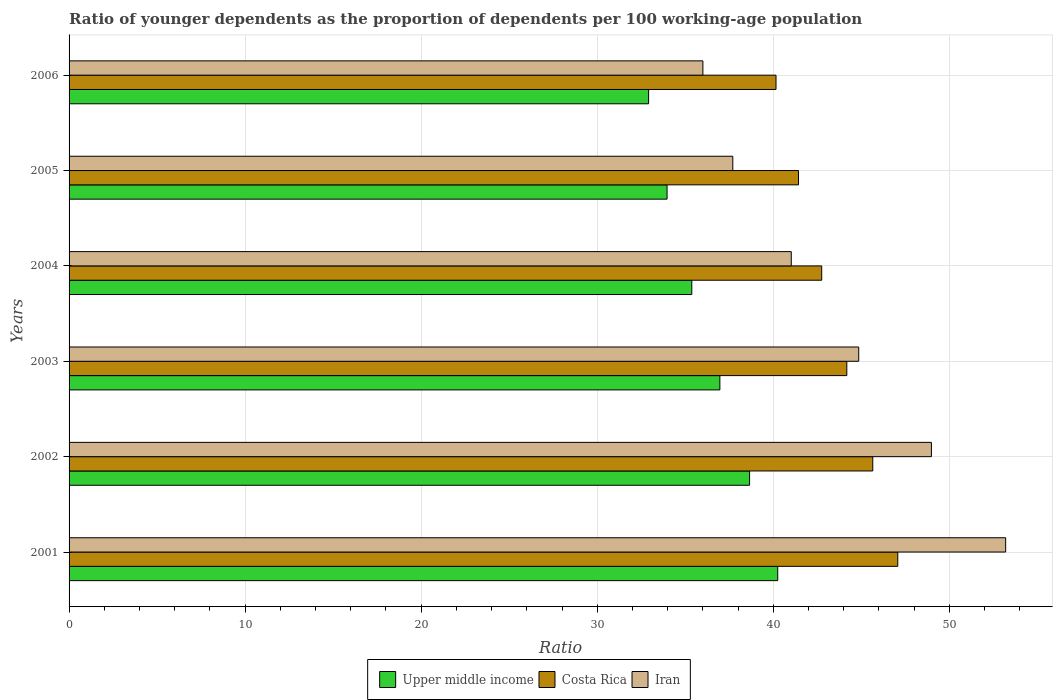How many bars are there on the 4th tick from the bottom?
Offer a very short reply. 3. What is the age dependency ratio(young) in Iran in 2002?
Offer a very short reply. 48.98. Across all years, what is the maximum age dependency ratio(young) in Upper middle income?
Offer a terse response. 40.25. Across all years, what is the minimum age dependency ratio(young) in Costa Rica?
Ensure brevity in your answer.  40.16. In which year was the age dependency ratio(young) in Upper middle income minimum?
Your response must be concise. 2006. What is the total age dependency ratio(young) in Upper middle income in the graph?
Keep it short and to the point. 218.13. What is the difference between the age dependency ratio(young) in Costa Rica in 2002 and that in 2006?
Keep it short and to the point. 5.5. What is the difference between the age dependency ratio(young) in Iran in 2006 and the age dependency ratio(young) in Upper middle income in 2005?
Offer a terse response. 2.04. What is the average age dependency ratio(young) in Costa Rica per year?
Your answer should be compact. 43.54. In the year 2004, what is the difference between the age dependency ratio(young) in Costa Rica and age dependency ratio(young) in Iran?
Ensure brevity in your answer.  1.73. What is the ratio of the age dependency ratio(young) in Costa Rica in 2003 to that in 2004?
Offer a very short reply. 1.03. What is the difference between the highest and the second highest age dependency ratio(young) in Iran?
Keep it short and to the point. 4.22. What is the difference between the highest and the lowest age dependency ratio(young) in Iran?
Make the answer very short. 17.2. What does the 3rd bar from the top in 2006 represents?
Make the answer very short. Upper middle income. What does the 1st bar from the bottom in 2002 represents?
Provide a succinct answer. Upper middle income. Is it the case that in every year, the sum of the age dependency ratio(young) in Upper middle income and age dependency ratio(young) in Costa Rica is greater than the age dependency ratio(young) in Iran?
Provide a short and direct response. Yes. Are all the bars in the graph horizontal?
Provide a succinct answer. Yes. How many years are there in the graph?
Make the answer very short. 6. What is the difference between two consecutive major ticks on the X-axis?
Make the answer very short. 10. Are the values on the major ticks of X-axis written in scientific E-notation?
Offer a very short reply. No. Does the graph contain grids?
Your response must be concise. Yes. How many legend labels are there?
Your answer should be compact. 3. How are the legend labels stacked?
Make the answer very short. Horizontal. What is the title of the graph?
Give a very brief answer. Ratio of younger dependents as the proportion of dependents per 100 working-age population. Does "Morocco" appear as one of the legend labels in the graph?
Give a very brief answer. No. What is the label or title of the X-axis?
Give a very brief answer. Ratio. What is the label or title of the Y-axis?
Offer a very short reply. Years. What is the Ratio in Upper middle income in 2001?
Your answer should be very brief. 40.25. What is the Ratio of Costa Rica in 2001?
Offer a very short reply. 47.07. What is the Ratio in Iran in 2001?
Ensure brevity in your answer.  53.2. What is the Ratio of Upper middle income in 2002?
Your response must be concise. 38.65. What is the Ratio in Costa Rica in 2002?
Offer a very short reply. 45.65. What is the Ratio of Iran in 2002?
Make the answer very short. 48.98. What is the Ratio in Upper middle income in 2003?
Provide a short and direct response. 36.97. What is the Ratio of Costa Rica in 2003?
Make the answer very short. 44.18. What is the Ratio in Iran in 2003?
Make the answer very short. 44.85. What is the Ratio in Upper middle income in 2004?
Your answer should be very brief. 35.37. What is the Ratio of Costa Rica in 2004?
Make the answer very short. 42.75. What is the Ratio in Iran in 2004?
Provide a succinct answer. 41.02. What is the Ratio in Upper middle income in 2005?
Give a very brief answer. 33.97. What is the Ratio in Costa Rica in 2005?
Make the answer very short. 41.43. What is the Ratio in Iran in 2005?
Keep it short and to the point. 37.7. What is the Ratio of Upper middle income in 2006?
Offer a terse response. 32.92. What is the Ratio in Costa Rica in 2006?
Offer a terse response. 40.16. What is the Ratio in Iran in 2006?
Provide a short and direct response. 36. Across all years, what is the maximum Ratio of Upper middle income?
Your answer should be compact. 40.25. Across all years, what is the maximum Ratio of Costa Rica?
Your answer should be very brief. 47.07. Across all years, what is the maximum Ratio of Iran?
Provide a short and direct response. 53.2. Across all years, what is the minimum Ratio of Upper middle income?
Keep it short and to the point. 32.92. Across all years, what is the minimum Ratio in Costa Rica?
Offer a terse response. 40.16. Across all years, what is the minimum Ratio of Iran?
Offer a terse response. 36. What is the total Ratio of Upper middle income in the graph?
Offer a terse response. 218.13. What is the total Ratio of Costa Rica in the graph?
Provide a short and direct response. 261.24. What is the total Ratio in Iran in the graph?
Offer a terse response. 261.76. What is the difference between the Ratio of Upper middle income in 2001 and that in 2002?
Give a very brief answer. 1.6. What is the difference between the Ratio of Costa Rica in 2001 and that in 2002?
Ensure brevity in your answer.  1.42. What is the difference between the Ratio in Iran in 2001 and that in 2002?
Make the answer very short. 4.22. What is the difference between the Ratio in Upper middle income in 2001 and that in 2003?
Make the answer very short. 3.29. What is the difference between the Ratio of Costa Rica in 2001 and that in 2003?
Offer a terse response. 2.9. What is the difference between the Ratio of Iran in 2001 and that in 2003?
Your answer should be very brief. 8.35. What is the difference between the Ratio in Upper middle income in 2001 and that in 2004?
Your answer should be compact. 4.88. What is the difference between the Ratio of Costa Rica in 2001 and that in 2004?
Your response must be concise. 4.32. What is the difference between the Ratio of Iran in 2001 and that in 2004?
Offer a very short reply. 12.18. What is the difference between the Ratio of Upper middle income in 2001 and that in 2005?
Keep it short and to the point. 6.29. What is the difference between the Ratio of Costa Rica in 2001 and that in 2005?
Keep it short and to the point. 5.64. What is the difference between the Ratio of Iran in 2001 and that in 2005?
Give a very brief answer. 15.5. What is the difference between the Ratio in Upper middle income in 2001 and that in 2006?
Give a very brief answer. 7.33. What is the difference between the Ratio in Costa Rica in 2001 and that in 2006?
Make the answer very short. 6.92. What is the difference between the Ratio in Iran in 2001 and that in 2006?
Offer a terse response. 17.2. What is the difference between the Ratio of Upper middle income in 2002 and that in 2003?
Offer a very short reply. 1.69. What is the difference between the Ratio of Costa Rica in 2002 and that in 2003?
Your answer should be very brief. 1.47. What is the difference between the Ratio of Iran in 2002 and that in 2003?
Your response must be concise. 4.13. What is the difference between the Ratio in Upper middle income in 2002 and that in 2004?
Provide a short and direct response. 3.28. What is the difference between the Ratio in Costa Rica in 2002 and that in 2004?
Ensure brevity in your answer.  2.9. What is the difference between the Ratio of Iran in 2002 and that in 2004?
Make the answer very short. 7.96. What is the difference between the Ratio in Upper middle income in 2002 and that in 2005?
Ensure brevity in your answer.  4.69. What is the difference between the Ratio of Costa Rica in 2002 and that in 2005?
Give a very brief answer. 4.22. What is the difference between the Ratio of Iran in 2002 and that in 2005?
Keep it short and to the point. 11.28. What is the difference between the Ratio of Upper middle income in 2002 and that in 2006?
Your response must be concise. 5.73. What is the difference between the Ratio in Costa Rica in 2002 and that in 2006?
Make the answer very short. 5.5. What is the difference between the Ratio of Iran in 2002 and that in 2006?
Your answer should be very brief. 12.98. What is the difference between the Ratio in Upper middle income in 2003 and that in 2004?
Provide a short and direct response. 1.6. What is the difference between the Ratio in Costa Rica in 2003 and that in 2004?
Offer a terse response. 1.43. What is the difference between the Ratio of Iran in 2003 and that in 2004?
Keep it short and to the point. 3.83. What is the difference between the Ratio of Upper middle income in 2003 and that in 2005?
Ensure brevity in your answer.  3. What is the difference between the Ratio in Costa Rica in 2003 and that in 2005?
Make the answer very short. 2.74. What is the difference between the Ratio in Iran in 2003 and that in 2005?
Offer a very short reply. 7.15. What is the difference between the Ratio in Upper middle income in 2003 and that in 2006?
Keep it short and to the point. 4.05. What is the difference between the Ratio of Costa Rica in 2003 and that in 2006?
Offer a terse response. 4.02. What is the difference between the Ratio of Iran in 2003 and that in 2006?
Ensure brevity in your answer.  8.85. What is the difference between the Ratio of Upper middle income in 2004 and that in 2005?
Your answer should be compact. 1.4. What is the difference between the Ratio in Costa Rica in 2004 and that in 2005?
Give a very brief answer. 1.32. What is the difference between the Ratio of Iran in 2004 and that in 2005?
Provide a short and direct response. 3.32. What is the difference between the Ratio in Upper middle income in 2004 and that in 2006?
Make the answer very short. 2.45. What is the difference between the Ratio in Costa Rica in 2004 and that in 2006?
Your answer should be very brief. 2.6. What is the difference between the Ratio of Iran in 2004 and that in 2006?
Your answer should be compact. 5.02. What is the difference between the Ratio of Upper middle income in 2005 and that in 2006?
Offer a terse response. 1.05. What is the difference between the Ratio in Costa Rica in 2005 and that in 2006?
Offer a terse response. 1.28. What is the difference between the Ratio in Iran in 2005 and that in 2006?
Provide a succinct answer. 1.7. What is the difference between the Ratio in Upper middle income in 2001 and the Ratio in Costa Rica in 2002?
Ensure brevity in your answer.  -5.4. What is the difference between the Ratio of Upper middle income in 2001 and the Ratio of Iran in 2002?
Offer a terse response. -8.73. What is the difference between the Ratio in Costa Rica in 2001 and the Ratio in Iran in 2002?
Provide a short and direct response. -1.91. What is the difference between the Ratio in Upper middle income in 2001 and the Ratio in Costa Rica in 2003?
Provide a succinct answer. -3.92. What is the difference between the Ratio in Upper middle income in 2001 and the Ratio in Iran in 2003?
Your response must be concise. -4.6. What is the difference between the Ratio of Costa Rica in 2001 and the Ratio of Iran in 2003?
Your response must be concise. 2.22. What is the difference between the Ratio of Upper middle income in 2001 and the Ratio of Costa Rica in 2004?
Ensure brevity in your answer.  -2.5. What is the difference between the Ratio of Upper middle income in 2001 and the Ratio of Iran in 2004?
Keep it short and to the point. -0.77. What is the difference between the Ratio of Costa Rica in 2001 and the Ratio of Iran in 2004?
Offer a terse response. 6.05. What is the difference between the Ratio of Upper middle income in 2001 and the Ratio of Costa Rica in 2005?
Your answer should be very brief. -1.18. What is the difference between the Ratio of Upper middle income in 2001 and the Ratio of Iran in 2005?
Your answer should be compact. 2.55. What is the difference between the Ratio in Costa Rica in 2001 and the Ratio in Iran in 2005?
Offer a very short reply. 9.37. What is the difference between the Ratio in Upper middle income in 2001 and the Ratio in Costa Rica in 2006?
Offer a terse response. 0.1. What is the difference between the Ratio in Upper middle income in 2001 and the Ratio in Iran in 2006?
Your answer should be compact. 4.25. What is the difference between the Ratio of Costa Rica in 2001 and the Ratio of Iran in 2006?
Offer a terse response. 11.07. What is the difference between the Ratio in Upper middle income in 2002 and the Ratio in Costa Rica in 2003?
Keep it short and to the point. -5.52. What is the difference between the Ratio of Upper middle income in 2002 and the Ratio of Iran in 2003?
Your response must be concise. -6.2. What is the difference between the Ratio in Costa Rica in 2002 and the Ratio in Iran in 2003?
Offer a terse response. 0.8. What is the difference between the Ratio in Upper middle income in 2002 and the Ratio in Costa Rica in 2004?
Ensure brevity in your answer.  -4.1. What is the difference between the Ratio in Upper middle income in 2002 and the Ratio in Iran in 2004?
Ensure brevity in your answer.  -2.37. What is the difference between the Ratio in Costa Rica in 2002 and the Ratio in Iran in 2004?
Your answer should be compact. 4.63. What is the difference between the Ratio of Upper middle income in 2002 and the Ratio of Costa Rica in 2005?
Your answer should be compact. -2.78. What is the difference between the Ratio in Upper middle income in 2002 and the Ratio in Iran in 2005?
Offer a very short reply. 0.95. What is the difference between the Ratio of Costa Rica in 2002 and the Ratio of Iran in 2005?
Give a very brief answer. 7.95. What is the difference between the Ratio of Upper middle income in 2002 and the Ratio of Costa Rica in 2006?
Your response must be concise. -1.5. What is the difference between the Ratio in Upper middle income in 2002 and the Ratio in Iran in 2006?
Give a very brief answer. 2.65. What is the difference between the Ratio of Costa Rica in 2002 and the Ratio of Iran in 2006?
Offer a very short reply. 9.65. What is the difference between the Ratio of Upper middle income in 2003 and the Ratio of Costa Rica in 2004?
Your answer should be compact. -5.78. What is the difference between the Ratio of Upper middle income in 2003 and the Ratio of Iran in 2004?
Make the answer very short. -4.06. What is the difference between the Ratio in Costa Rica in 2003 and the Ratio in Iran in 2004?
Give a very brief answer. 3.15. What is the difference between the Ratio in Upper middle income in 2003 and the Ratio in Costa Rica in 2005?
Ensure brevity in your answer.  -4.47. What is the difference between the Ratio of Upper middle income in 2003 and the Ratio of Iran in 2005?
Offer a very short reply. -0.73. What is the difference between the Ratio in Costa Rica in 2003 and the Ratio in Iran in 2005?
Ensure brevity in your answer.  6.48. What is the difference between the Ratio in Upper middle income in 2003 and the Ratio in Costa Rica in 2006?
Your response must be concise. -3.19. What is the difference between the Ratio in Upper middle income in 2003 and the Ratio in Iran in 2006?
Provide a succinct answer. 0.96. What is the difference between the Ratio in Costa Rica in 2003 and the Ratio in Iran in 2006?
Ensure brevity in your answer.  8.17. What is the difference between the Ratio of Upper middle income in 2004 and the Ratio of Costa Rica in 2005?
Keep it short and to the point. -6.06. What is the difference between the Ratio in Upper middle income in 2004 and the Ratio in Iran in 2005?
Provide a succinct answer. -2.33. What is the difference between the Ratio in Costa Rica in 2004 and the Ratio in Iran in 2005?
Your response must be concise. 5.05. What is the difference between the Ratio in Upper middle income in 2004 and the Ratio in Costa Rica in 2006?
Make the answer very short. -4.78. What is the difference between the Ratio of Upper middle income in 2004 and the Ratio of Iran in 2006?
Provide a succinct answer. -0.63. What is the difference between the Ratio of Costa Rica in 2004 and the Ratio of Iran in 2006?
Your answer should be very brief. 6.75. What is the difference between the Ratio of Upper middle income in 2005 and the Ratio of Costa Rica in 2006?
Provide a short and direct response. -6.19. What is the difference between the Ratio of Upper middle income in 2005 and the Ratio of Iran in 2006?
Offer a terse response. -2.04. What is the difference between the Ratio in Costa Rica in 2005 and the Ratio in Iran in 2006?
Keep it short and to the point. 5.43. What is the average Ratio of Upper middle income per year?
Provide a short and direct response. 36.35. What is the average Ratio in Costa Rica per year?
Ensure brevity in your answer.  43.54. What is the average Ratio of Iran per year?
Provide a succinct answer. 43.63. In the year 2001, what is the difference between the Ratio in Upper middle income and Ratio in Costa Rica?
Keep it short and to the point. -6.82. In the year 2001, what is the difference between the Ratio in Upper middle income and Ratio in Iran?
Offer a terse response. -12.95. In the year 2001, what is the difference between the Ratio of Costa Rica and Ratio of Iran?
Your answer should be compact. -6.13. In the year 2002, what is the difference between the Ratio in Upper middle income and Ratio in Costa Rica?
Provide a succinct answer. -7. In the year 2002, what is the difference between the Ratio of Upper middle income and Ratio of Iran?
Offer a very short reply. -10.33. In the year 2002, what is the difference between the Ratio of Costa Rica and Ratio of Iran?
Ensure brevity in your answer.  -3.33. In the year 2003, what is the difference between the Ratio in Upper middle income and Ratio in Costa Rica?
Ensure brevity in your answer.  -7.21. In the year 2003, what is the difference between the Ratio in Upper middle income and Ratio in Iran?
Your answer should be very brief. -7.89. In the year 2003, what is the difference between the Ratio of Costa Rica and Ratio of Iran?
Offer a very short reply. -0.68. In the year 2004, what is the difference between the Ratio of Upper middle income and Ratio of Costa Rica?
Offer a terse response. -7.38. In the year 2004, what is the difference between the Ratio in Upper middle income and Ratio in Iran?
Your response must be concise. -5.65. In the year 2004, what is the difference between the Ratio of Costa Rica and Ratio of Iran?
Make the answer very short. 1.73. In the year 2005, what is the difference between the Ratio of Upper middle income and Ratio of Costa Rica?
Your answer should be very brief. -7.47. In the year 2005, what is the difference between the Ratio in Upper middle income and Ratio in Iran?
Provide a short and direct response. -3.73. In the year 2005, what is the difference between the Ratio in Costa Rica and Ratio in Iran?
Offer a very short reply. 3.73. In the year 2006, what is the difference between the Ratio of Upper middle income and Ratio of Costa Rica?
Your answer should be very brief. -7.24. In the year 2006, what is the difference between the Ratio of Upper middle income and Ratio of Iran?
Your response must be concise. -3.08. In the year 2006, what is the difference between the Ratio of Costa Rica and Ratio of Iran?
Offer a very short reply. 4.15. What is the ratio of the Ratio in Upper middle income in 2001 to that in 2002?
Provide a short and direct response. 1.04. What is the ratio of the Ratio of Costa Rica in 2001 to that in 2002?
Make the answer very short. 1.03. What is the ratio of the Ratio of Iran in 2001 to that in 2002?
Ensure brevity in your answer.  1.09. What is the ratio of the Ratio in Upper middle income in 2001 to that in 2003?
Your response must be concise. 1.09. What is the ratio of the Ratio in Costa Rica in 2001 to that in 2003?
Your answer should be compact. 1.07. What is the ratio of the Ratio of Iran in 2001 to that in 2003?
Your response must be concise. 1.19. What is the ratio of the Ratio in Upper middle income in 2001 to that in 2004?
Provide a succinct answer. 1.14. What is the ratio of the Ratio in Costa Rica in 2001 to that in 2004?
Keep it short and to the point. 1.1. What is the ratio of the Ratio of Iran in 2001 to that in 2004?
Ensure brevity in your answer.  1.3. What is the ratio of the Ratio of Upper middle income in 2001 to that in 2005?
Give a very brief answer. 1.19. What is the ratio of the Ratio of Costa Rica in 2001 to that in 2005?
Offer a terse response. 1.14. What is the ratio of the Ratio in Iran in 2001 to that in 2005?
Give a very brief answer. 1.41. What is the ratio of the Ratio of Upper middle income in 2001 to that in 2006?
Your answer should be very brief. 1.22. What is the ratio of the Ratio of Costa Rica in 2001 to that in 2006?
Offer a terse response. 1.17. What is the ratio of the Ratio in Iran in 2001 to that in 2006?
Make the answer very short. 1.48. What is the ratio of the Ratio of Upper middle income in 2002 to that in 2003?
Offer a very short reply. 1.05. What is the ratio of the Ratio in Costa Rica in 2002 to that in 2003?
Offer a terse response. 1.03. What is the ratio of the Ratio of Iran in 2002 to that in 2003?
Keep it short and to the point. 1.09. What is the ratio of the Ratio of Upper middle income in 2002 to that in 2004?
Give a very brief answer. 1.09. What is the ratio of the Ratio in Costa Rica in 2002 to that in 2004?
Provide a short and direct response. 1.07. What is the ratio of the Ratio in Iran in 2002 to that in 2004?
Your answer should be compact. 1.19. What is the ratio of the Ratio of Upper middle income in 2002 to that in 2005?
Your answer should be compact. 1.14. What is the ratio of the Ratio of Costa Rica in 2002 to that in 2005?
Offer a very short reply. 1.1. What is the ratio of the Ratio in Iran in 2002 to that in 2005?
Ensure brevity in your answer.  1.3. What is the ratio of the Ratio in Upper middle income in 2002 to that in 2006?
Provide a short and direct response. 1.17. What is the ratio of the Ratio in Costa Rica in 2002 to that in 2006?
Provide a succinct answer. 1.14. What is the ratio of the Ratio in Iran in 2002 to that in 2006?
Your answer should be very brief. 1.36. What is the ratio of the Ratio in Upper middle income in 2003 to that in 2004?
Offer a very short reply. 1.05. What is the ratio of the Ratio of Costa Rica in 2003 to that in 2004?
Offer a very short reply. 1.03. What is the ratio of the Ratio in Iran in 2003 to that in 2004?
Your answer should be compact. 1.09. What is the ratio of the Ratio in Upper middle income in 2003 to that in 2005?
Keep it short and to the point. 1.09. What is the ratio of the Ratio of Costa Rica in 2003 to that in 2005?
Make the answer very short. 1.07. What is the ratio of the Ratio in Iran in 2003 to that in 2005?
Your answer should be very brief. 1.19. What is the ratio of the Ratio in Upper middle income in 2003 to that in 2006?
Your answer should be compact. 1.12. What is the ratio of the Ratio in Costa Rica in 2003 to that in 2006?
Offer a very short reply. 1.1. What is the ratio of the Ratio of Iran in 2003 to that in 2006?
Your response must be concise. 1.25. What is the ratio of the Ratio of Upper middle income in 2004 to that in 2005?
Make the answer very short. 1.04. What is the ratio of the Ratio in Costa Rica in 2004 to that in 2005?
Your answer should be very brief. 1.03. What is the ratio of the Ratio of Iran in 2004 to that in 2005?
Offer a terse response. 1.09. What is the ratio of the Ratio of Upper middle income in 2004 to that in 2006?
Your response must be concise. 1.07. What is the ratio of the Ratio of Costa Rica in 2004 to that in 2006?
Your answer should be very brief. 1.06. What is the ratio of the Ratio in Iran in 2004 to that in 2006?
Make the answer very short. 1.14. What is the ratio of the Ratio of Upper middle income in 2005 to that in 2006?
Give a very brief answer. 1.03. What is the ratio of the Ratio in Costa Rica in 2005 to that in 2006?
Make the answer very short. 1.03. What is the ratio of the Ratio of Iran in 2005 to that in 2006?
Your answer should be very brief. 1.05. What is the difference between the highest and the second highest Ratio of Upper middle income?
Your response must be concise. 1.6. What is the difference between the highest and the second highest Ratio in Costa Rica?
Offer a very short reply. 1.42. What is the difference between the highest and the second highest Ratio of Iran?
Provide a succinct answer. 4.22. What is the difference between the highest and the lowest Ratio in Upper middle income?
Make the answer very short. 7.33. What is the difference between the highest and the lowest Ratio of Costa Rica?
Give a very brief answer. 6.92. What is the difference between the highest and the lowest Ratio of Iran?
Provide a short and direct response. 17.2. 